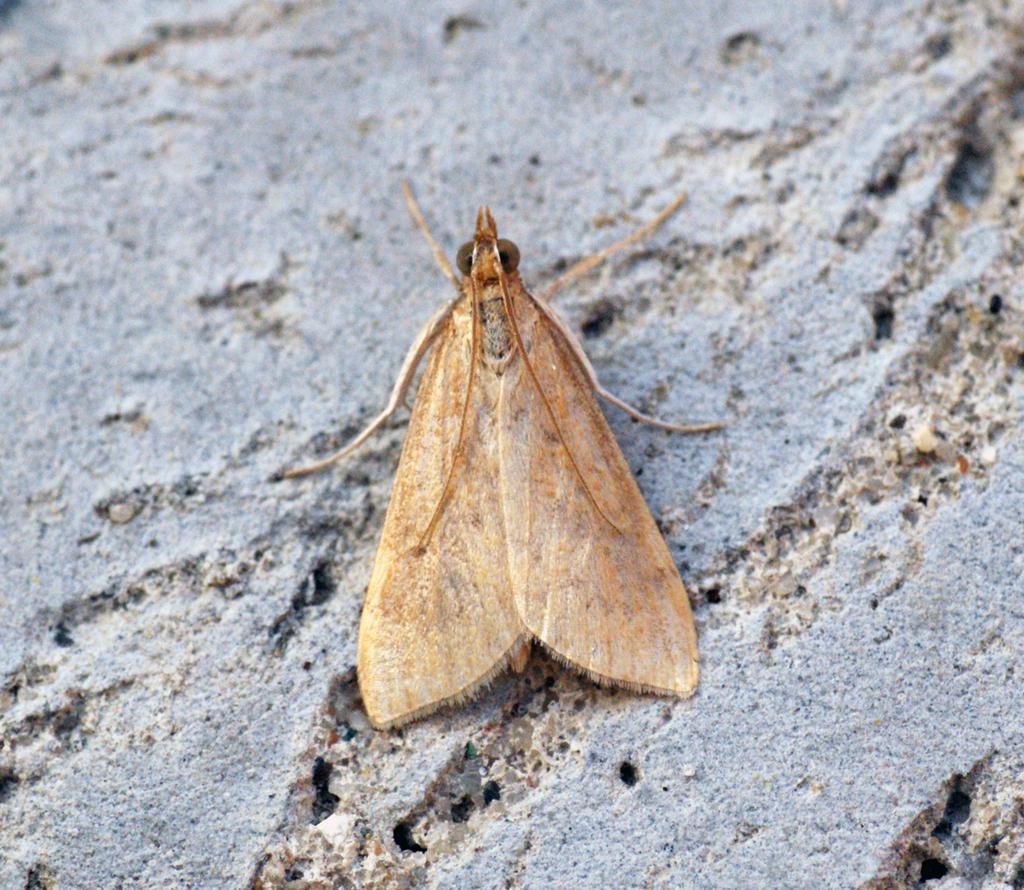Describe this image in one or two sentences. In this image there is a moth visible may be on rock. 